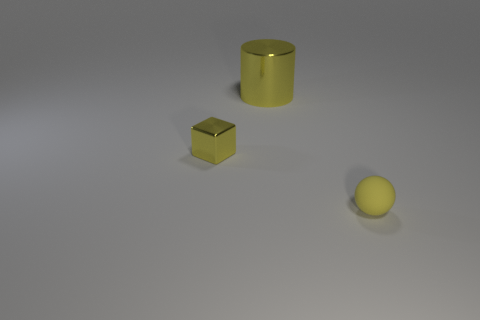Add 1 tiny yellow metallic cubes. How many objects exist? 4 Subtract all cylinders. How many objects are left? 2 Add 1 small rubber things. How many small rubber things exist? 2 Subtract 0 purple cylinders. How many objects are left? 3 Subtract all metallic things. Subtract all small yellow spheres. How many objects are left? 0 Add 2 small yellow shiny objects. How many small yellow shiny objects are left? 3 